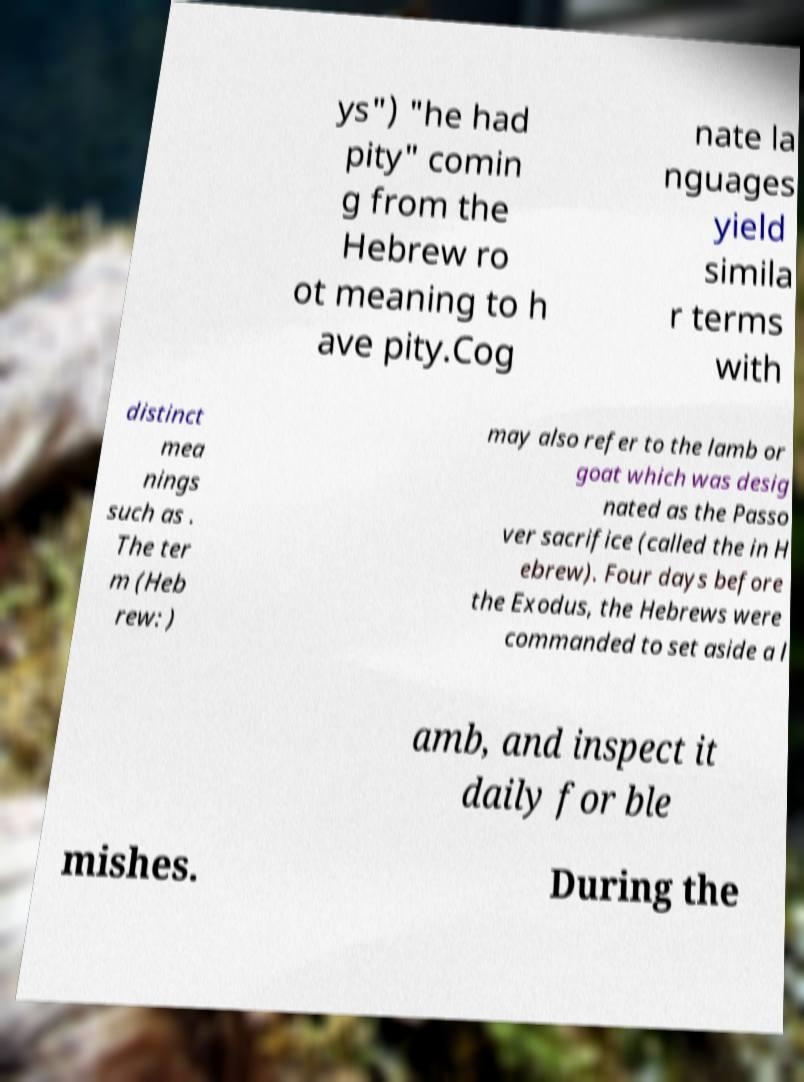Could you assist in decoding the text presented in this image and type it out clearly? ys") "he had pity" comin g from the Hebrew ro ot meaning to h ave pity.Cog nate la nguages yield simila r terms with distinct mea nings such as . The ter m (Heb rew: ) may also refer to the lamb or goat which was desig nated as the Passo ver sacrifice (called the in H ebrew). Four days before the Exodus, the Hebrews were commanded to set aside a l amb, and inspect it daily for ble mishes. During the 